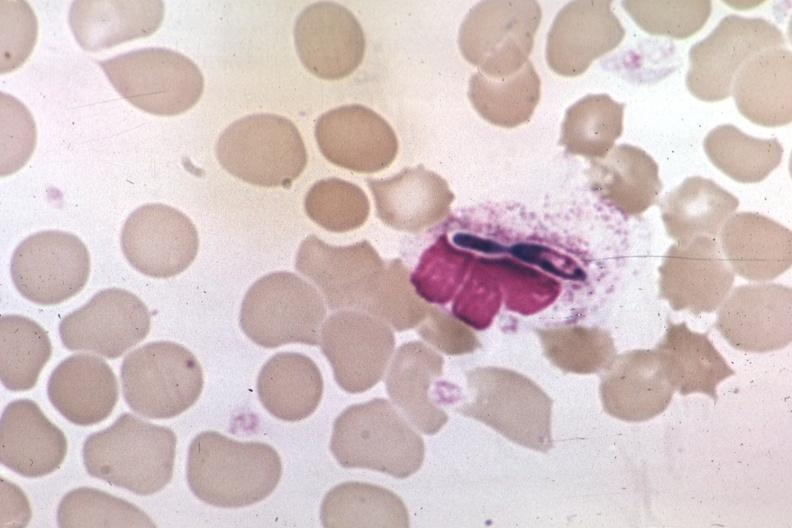s absence of palpebral fissure cleft palate present?
Answer the question using a single word or phrase. No 